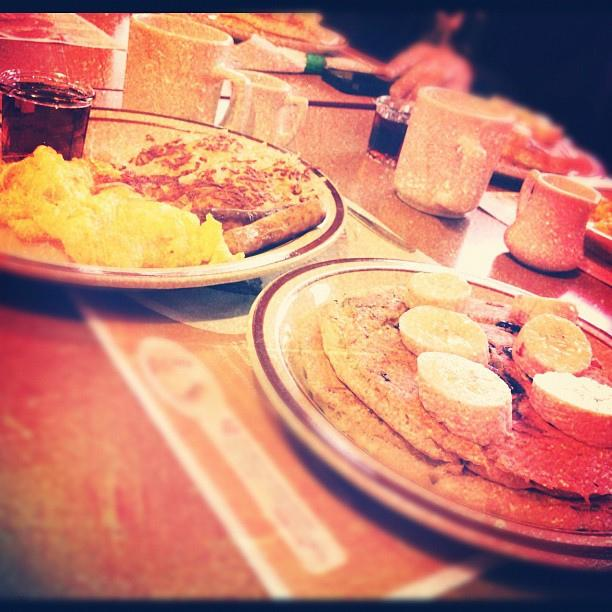What color are the fruits sliced out on top of the pancake? yellow 